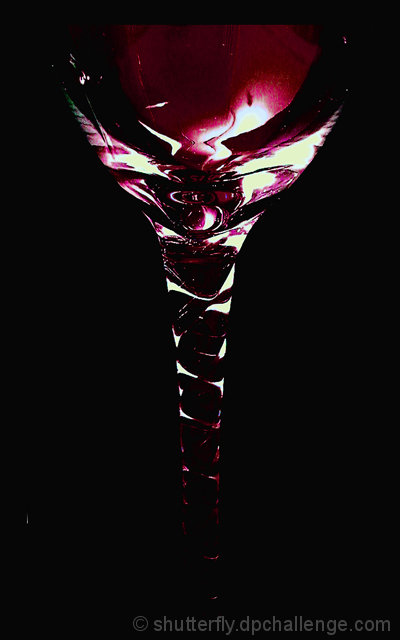What kind of mood does this image evoke? The image evokes a sense of mystery and elegance, possibly suggesting a sophisticated event or an intimate moment at a low-lit venue. 